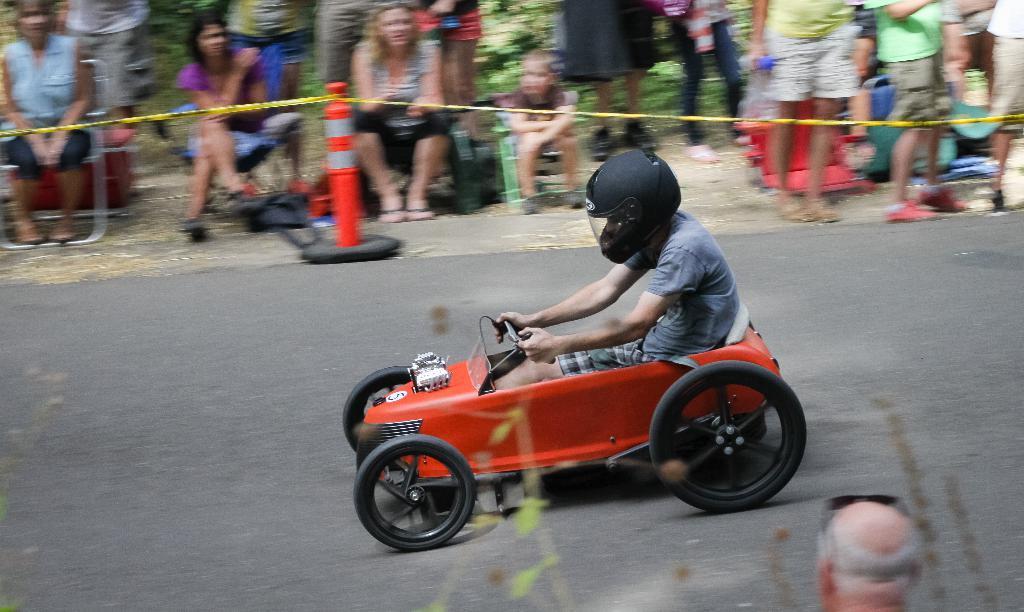Can you describe this image briefly? In this image I can see a person driving a small red car. He is wearing a helmet. There is a rope fence at the back and people are present behind it. There is a person at the front. 